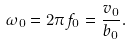<formula> <loc_0><loc_0><loc_500><loc_500>\omega _ { 0 } = 2 \pi f _ { 0 } = \frac { v _ { 0 } } { b _ { 0 } } .</formula> 